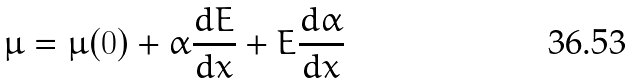<formula> <loc_0><loc_0><loc_500><loc_500>\mu = \mu ( 0 ) + \alpha \frac { d E } { d x } + E \frac { d \alpha } { d x }</formula> 